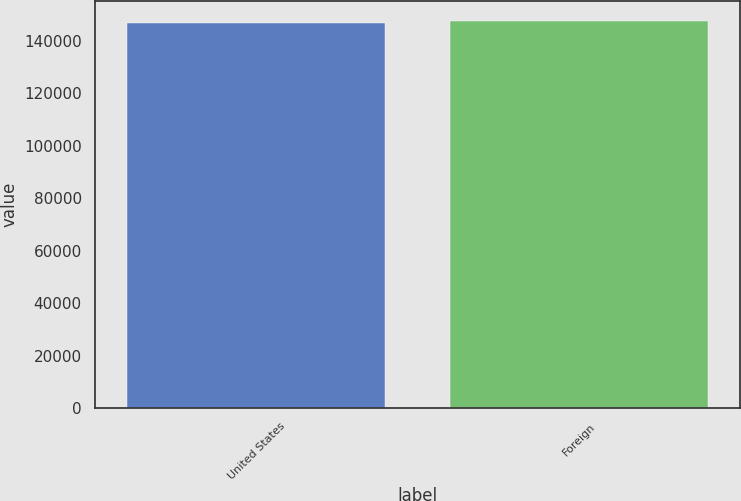Convert chart. <chart><loc_0><loc_0><loc_500><loc_500><bar_chart><fcel>United States<fcel>Foreign<nl><fcel>146575<fcel>147597<nl></chart> 